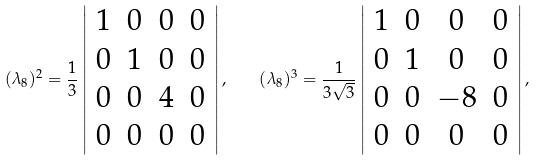Convert formula to latex. <formula><loc_0><loc_0><loc_500><loc_500>( \lambda _ { 8 } ) ^ { 2 } = \frac { 1 } { 3 } \left | \begin{array} { c c c c } 1 & 0 & 0 & 0 \\ 0 & 1 & 0 & 0 \\ 0 & 0 & 4 & 0 \\ 0 & 0 & 0 & 0 \end{array} \right | , \quad ( \lambda _ { 8 } ) ^ { 3 } = \frac { 1 } { 3 \sqrt { 3 } } \left | \begin{array} { c c c c } 1 & 0 & 0 & 0 \\ 0 & 1 & 0 & 0 \\ 0 & 0 & - 8 & 0 \\ 0 & 0 & 0 & 0 \end{array} \right | ,</formula> 